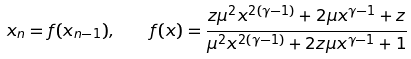Convert formula to latex. <formula><loc_0><loc_0><loc_500><loc_500>x _ { n } = f ( x _ { n - 1 } ) , \quad f ( x ) = \frac { z { \mu } ^ { 2 } x ^ { 2 ( \gamma - 1 ) } + 2 \mu x ^ { \gamma - 1 } + z } { { \mu } ^ { 2 } x ^ { 2 ( \gamma - 1 ) } + 2 z \mu x ^ { \gamma - 1 } + 1 }</formula> 